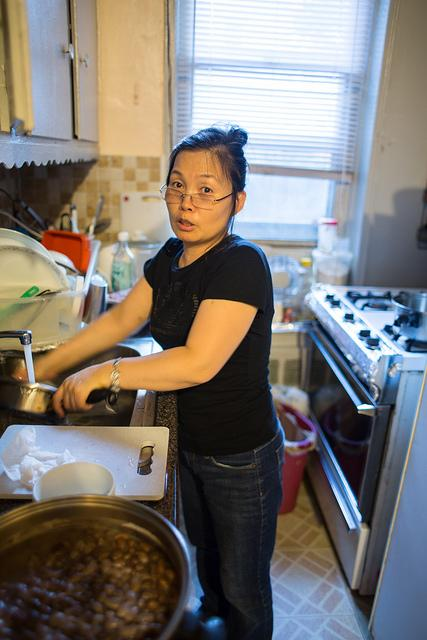What chore does the woman perform? washing dishes 